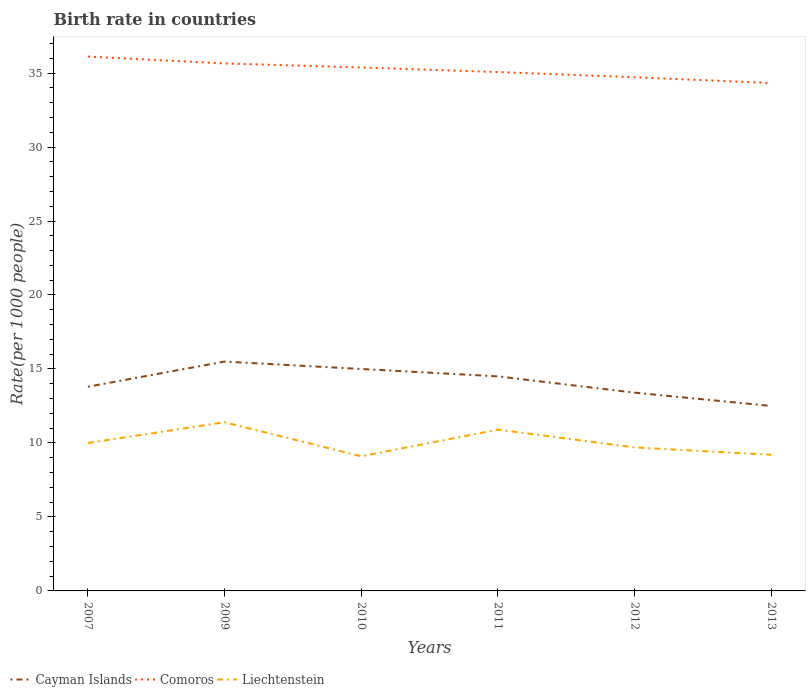How many different coloured lines are there?
Keep it short and to the point. 3. Does the line corresponding to Cayman Islands intersect with the line corresponding to Liechtenstein?
Offer a terse response. No. Across all years, what is the maximum birth rate in Liechtenstein?
Make the answer very short. 9.1. In which year was the birth rate in Comoros maximum?
Provide a succinct answer. 2013. What is the total birth rate in Cayman Islands in the graph?
Offer a terse response. 0.5. What is the difference between the highest and the second highest birth rate in Comoros?
Ensure brevity in your answer.  1.79. Is the birth rate in Cayman Islands strictly greater than the birth rate in Liechtenstein over the years?
Make the answer very short. No. How many years are there in the graph?
Your answer should be very brief. 6. What is the difference between two consecutive major ticks on the Y-axis?
Provide a short and direct response. 5. Are the values on the major ticks of Y-axis written in scientific E-notation?
Give a very brief answer. No. Does the graph contain any zero values?
Offer a very short reply. No. Does the graph contain grids?
Give a very brief answer. No. Where does the legend appear in the graph?
Provide a short and direct response. Bottom left. How many legend labels are there?
Ensure brevity in your answer.  3. What is the title of the graph?
Offer a very short reply. Birth rate in countries. What is the label or title of the Y-axis?
Your response must be concise. Rate(per 1000 people). What is the Rate(per 1000 people) of Cayman Islands in 2007?
Provide a short and direct response. 13.8. What is the Rate(per 1000 people) in Comoros in 2007?
Your answer should be very brief. 36.12. What is the Rate(per 1000 people) in Liechtenstein in 2007?
Provide a succinct answer. 10. What is the Rate(per 1000 people) in Comoros in 2009?
Provide a succinct answer. 35.65. What is the Rate(per 1000 people) in Comoros in 2010?
Provide a short and direct response. 35.38. What is the Rate(per 1000 people) in Liechtenstein in 2010?
Your answer should be compact. 9.1. What is the Rate(per 1000 people) of Comoros in 2011?
Your answer should be compact. 35.07. What is the Rate(per 1000 people) in Liechtenstein in 2011?
Offer a very short reply. 10.9. What is the Rate(per 1000 people) in Cayman Islands in 2012?
Offer a very short reply. 13.4. What is the Rate(per 1000 people) of Comoros in 2012?
Keep it short and to the point. 34.72. What is the Rate(per 1000 people) of Cayman Islands in 2013?
Your response must be concise. 12.5. What is the Rate(per 1000 people) in Comoros in 2013?
Your answer should be compact. 34.33. What is the Rate(per 1000 people) of Liechtenstein in 2013?
Ensure brevity in your answer.  9.2. Across all years, what is the maximum Rate(per 1000 people) of Cayman Islands?
Your answer should be very brief. 15.5. Across all years, what is the maximum Rate(per 1000 people) in Comoros?
Make the answer very short. 36.12. Across all years, what is the maximum Rate(per 1000 people) in Liechtenstein?
Give a very brief answer. 11.4. Across all years, what is the minimum Rate(per 1000 people) in Comoros?
Provide a short and direct response. 34.33. What is the total Rate(per 1000 people) in Cayman Islands in the graph?
Offer a terse response. 84.7. What is the total Rate(per 1000 people) of Comoros in the graph?
Your response must be concise. 211.25. What is the total Rate(per 1000 people) in Liechtenstein in the graph?
Keep it short and to the point. 60.3. What is the difference between the Rate(per 1000 people) of Comoros in 2007 and that in 2009?
Provide a short and direct response. 0.47. What is the difference between the Rate(per 1000 people) in Liechtenstein in 2007 and that in 2009?
Give a very brief answer. -1.4. What is the difference between the Rate(per 1000 people) in Cayman Islands in 2007 and that in 2010?
Make the answer very short. -1.2. What is the difference between the Rate(per 1000 people) of Comoros in 2007 and that in 2010?
Ensure brevity in your answer.  0.74. What is the difference between the Rate(per 1000 people) of Liechtenstein in 2007 and that in 2010?
Give a very brief answer. 0.9. What is the difference between the Rate(per 1000 people) of Comoros in 2007 and that in 2011?
Offer a very short reply. 1.05. What is the difference between the Rate(per 1000 people) of Cayman Islands in 2007 and that in 2012?
Keep it short and to the point. 0.4. What is the difference between the Rate(per 1000 people) in Comoros in 2007 and that in 2012?
Provide a short and direct response. 1.4. What is the difference between the Rate(per 1000 people) of Liechtenstein in 2007 and that in 2012?
Your answer should be very brief. 0.3. What is the difference between the Rate(per 1000 people) of Comoros in 2007 and that in 2013?
Your response must be concise. 1.79. What is the difference between the Rate(per 1000 people) of Liechtenstein in 2007 and that in 2013?
Offer a terse response. 0.8. What is the difference between the Rate(per 1000 people) of Cayman Islands in 2009 and that in 2010?
Give a very brief answer. 0.5. What is the difference between the Rate(per 1000 people) of Comoros in 2009 and that in 2010?
Ensure brevity in your answer.  0.27. What is the difference between the Rate(per 1000 people) of Liechtenstein in 2009 and that in 2010?
Your answer should be very brief. 2.3. What is the difference between the Rate(per 1000 people) of Comoros in 2009 and that in 2011?
Make the answer very short. 0.58. What is the difference between the Rate(per 1000 people) in Cayman Islands in 2009 and that in 2012?
Offer a very short reply. 2.1. What is the difference between the Rate(per 1000 people) in Liechtenstein in 2009 and that in 2012?
Your response must be concise. 1.7. What is the difference between the Rate(per 1000 people) of Cayman Islands in 2009 and that in 2013?
Offer a terse response. 3. What is the difference between the Rate(per 1000 people) of Comoros in 2009 and that in 2013?
Provide a short and direct response. 1.32. What is the difference between the Rate(per 1000 people) in Comoros in 2010 and that in 2011?
Provide a succinct answer. 0.31. What is the difference between the Rate(per 1000 people) in Comoros in 2010 and that in 2012?
Ensure brevity in your answer.  0.66. What is the difference between the Rate(per 1000 people) of Cayman Islands in 2010 and that in 2013?
Your response must be concise. 2.5. What is the difference between the Rate(per 1000 people) of Comoros in 2010 and that in 2013?
Your answer should be compact. 1.05. What is the difference between the Rate(per 1000 people) of Comoros in 2011 and that in 2012?
Your answer should be compact. 0.35. What is the difference between the Rate(per 1000 people) of Liechtenstein in 2011 and that in 2012?
Offer a very short reply. 1.2. What is the difference between the Rate(per 1000 people) in Cayman Islands in 2011 and that in 2013?
Your answer should be very brief. 2. What is the difference between the Rate(per 1000 people) of Comoros in 2011 and that in 2013?
Your answer should be compact. 0.74. What is the difference between the Rate(per 1000 people) of Comoros in 2012 and that in 2013?
Provide a succinct answer. 0.39. What is the difference between the Rate(per 1000 people) of Cayman Islands in 2007 and the Rate(per 1000 people) of Comoros in 2009?
Your answer should be compact. -21.85. What is the difference between the Rate(per 1000 people) of Cayman Islands in 2007 and the Rate(per 1000 people) of Liechtenstein in 2009?
Your answer should be very brief. 2.4. What is the difference between the Rate(per 1000 people) in Comoros in 2007 and the Rate(per 1000 people) in Liechtenstein in 2009?
Make the answer very short. 24.71. What is the difference between the Rate(per 1000 people) in Cayman Islands in 2007 and the Rate(per 1000 people) in Comoros in 2010?
Give a very brief answer. -21.58. What is the difference between the Rate(per 1000 people) of Comoros in 2007 and the Rate(per 1000 people) of Liechtenstein in 2010?
Keep it short and to the point. 27.02. What is the difference between the Rate(per 1000 people) in Cayman Islands in 2007 and the Rate(per 1000 people) in Comoros in 2011?
Give a very brief answer. -21.27. What is the difference between the Rate(per 1000 people) in Cayman Islands in 2007 and the Rate(per 1000 people) in Liechtenstein in 2011?
Ensure brevity in your answer.  2.9. What is the difference between the Rate(per 1000 people) in Comoros in 2007 and the Rate(per 1000 people) in Liechtenstein in 2011?
Give a very brief answer. 25.21. What is the difference between the Rate(per 1000 people) of Cayman Islands in 2007 and the Rate(per 1000 people) of Comoros in 2012?
Ensure brevity in your answer.  -20.92. What is the difference between the Rate(per 1000 people) of Comoros in 2007 and the Rate(per 1000 people) of Liechtenstein in 2012?
Your answer should be compact. 26.41. What is the difference between the Rate(per 1000 people) of Cayman Islands in 2007 and the Rate(per 1000 people) of Comoros in 2013?
Offer a very short reply. -20.53. What is the difference between the Rate(per 1000 people) in Cayman Islands in 2007 and the Rate(per 1000 people) in Liechtenstein in 2013?
Provide a succinct answer. 4.6. What is the difference between the Rate(per 1000 people) of Comoros in 2007 and the Rate(per 1000 people) of Liechtenstein in 2013?
Your answer should be compact. 26.91. What is the difference between the Rate(per 1000 people) in Cayman Islands in 2009 and the Rate(per 1000 people) in Comoros in 2010?
Ensure brevity in your answer.  -19.88. What is the difference between the Rate(per 1000 people) in Comoros in 2009 and the Rate(per 1000 people) in Liechtenstein in 2010?
Your answer should be very brief. 26.55. What is the difference between the Rate(per 1000 people) in Cayman Islands in 2009 and the Rate(per 1000 people) in Comoros in 2011?
Your answer should be very brief. -19.57. What is the difference between the Rate(per 1000 people) in Comoros in 2009 and the Rate(per 1000 people) in Liechtenstein in 2011?
Make the answer very short. 24.75. What is the difference between the Rate(per 1000 people) in Cayman Islands in 2009 and the Rate(per 1000 people) in Comoros in 2012?
Provide a succinct answer. -19.22. What is the difference between the Rate(per 1000 people) of Cayman Islands in 2009 and the Rate(per 1000 people) of Liechtenstein in 2012?
Ensure brevity in your answer.  5.8. What is the difference between the Rate(per 1000 people) of Comoros in 2009 and the Rate(per 1000 people) of Liechtenstein in 2012?
Provide a succinct answer. 25.95. What is the difference between the Rate(per 1000 people) in Cayman Islands in 2009 and the Rate(per 1000 people) in Comoros in 2013?
Your answer should be very brief. -18.83. What is the difference between the Rate(per 1000 people) of Cayman Islands in 2009 and the Rate(per 1000 people) of Liechtenstein in 2013?
Offer a terse response. 6.3. What is the difference between the Rate(per 1000 people) in Comoros in 2009 and the Rate(per 1000 people) in Liechtenstein in 2013?
Ensure brevity in your answer.  26.45. What is the difference between the Rate(per 1000 people) in Cayman Islands in 2010 and the Rate(per 1000 people) in Comoros in 2011?
Make the answer very short. -20.07. What is the difference between the Rate(per 1000 people) in Cayman Islands in 2010 and the Rate(per 1000 people) in Liechtenstein in 2011?
Give a very brief answer. 4.1. What is the difference between the Rate(per 1000 people) in Comoros in 2010 and the Rate(per 1000 people) in Liechtenstein in 2011?
Your response must be concise. 24.48. What is the difference between the Rate(per 1000 people) of Cayman Islands in 2010 and the Rate(per 1000 people) of Comoros in 2012?
Provide a succinct answer. -19.72. What is the difference between the Rate(per 1000 people) of Comoros in 2010 and the Rate(per 1000 people) of Liechtenstein in 2012?
Provide a succinct answer. 25.68. What is the difference between the Rate(per 1000 people) of Cayman Islands in 2010 and the Rate(per 1000 people) of Comoros in 2013?
Make the answer very short. -19.33. What is the difference between the Rate(per 1000 people) of Comoros in 2010 and the Rate(per 1000 people) of Liechtenstein in 2013?
Your answer should be compact. 26.18. What is the difference between the Rate(per 1000 people) of Cayman Islands in 2011 and the Rate(per 1000 people) of Comoros in 2012?
Ensure brevity in your answer.  -20.22. What is the difference between the Rate(per 1000 people) in Cayman Islands in 2011 and the Rate(per 1000 people) in Liechtenstein in 2012?
Your response must be concise. 4.8. What is the difference between the Rate(per 1000 people) of Comoros in 2011 and the Rate(per 1000 people) of Liechtenstein in 2012?
Ensure brevity in your answer.  25.37. What is the difference between the Rate(per 1000 people) in Cayman Islands in 2011 and the Rate(per 1000 people) in Comoros in 2013?
Keep it short and to the point. -19.83. What is the difference between the Rate(per 1000 people) in Cayman Islands in 2011 and the Rate(per 1000 people) in Liechtenstein in 2013?
Your answer should be very brief. 5.3. What is the difference between the Rate(per 1000 people) of Comoros in 2011 and the Rate(per 1000 people) of Liechtenstein in 2013?
Keep it short and to the point. 25.87. What is the difference between the Rate(per 1000 people) of Cayman Islands in 2012 and the Rate(per 1000 people) of Comoros in 2013?
Your response must be concise. -20.93. What is the difference between the Rate(per 1000 people) in Cayman Islands in 2012 and the Rate(per 1000 people) in Liechtenstein in 2013?
Offer a terse response. 4.2. What is the difference between the Rate(per 1000 people) in Comoros in 2012 and the Rate(per 1000 people) in Liechtenstein in 2013?
Offer a terse response. 25.52. What is the average Rate(per 1000 people) in Cayman Islands per year?
Offer a very short reply. 14.12. What is the average Rate(per 1000 people) in Comoros per year?
Your response must be concise. 35.21. What is the average Rate(per 1000 people) of Liechtenstein per year?
Your answer should be very brief. 10.05. In the year 2007, what is the difference between the Rate(per 1000 people) of Cayman Islands and Rate(per 1000 people) of Comoros?
Provide a succinct answer. -22.32. In the year 2007, what is the difference between the Rate(per 1000 people) in Cayman Islands and Rate(per 1000 people) in Liechtenstein?
Make the answer very short. 3.8. In the year 2007, what is the difference between the Rate(per 1000 people) of Comoros and Rate(per 1000 people) of Liechtenstein?
Offer a terse response. 26.11. In the year 2009, what is the difference between the Rate(per 1000 people) of Cayman Islands and Rate(per 1000 people) of Comoros?
Offer a very short reply. -20.15. In the year 2009, what is the difference between the Rate(per 1000 people) in Comoros and Rate(per 1000 people) in Liechtenstein?
Give a very brief answer. 24.25. In the year 2010, what is the difference between the Rate(per 1000 people) of Cayman Islands and Rate(per 1000 people) of Comoros?
Provide a succinct answer. -20.38. In the year 2010, what is the difference between the Rate(per 1000 people) in Comoros and Rate(per 1000 people) in Liechtenstein?
Give a very brief answer. 26.28. In the year 2011, what is the difference between the Rate(per 1000 people) of Cayman Islands and Rate(per 1000 people) of Comoros?
Give a very brief answer. -20.57. In the year 2011, what is the difference between the Rate(per 1000 people) of Comoros and Rate(per 1000 people) of Liechtenstein?
Make the answer very short. 24.17. In the year 2012, what is the difference between the Rate(per 1000 people) in Cayman Islands and Rate(per 1000 people) in Comoros?
Provide a short and direct response. -21.32. In the year 2012, what is the difference between the Rate(per 1000 people) in Comoros and Rate(per 1000 people) in Liechtenstein?
Make the answer very short. 25.02. In the year 2013, what is the difference between the Rate(per 1000 people) in Cayman Islands and Rate(per 1000 people) in Comoros?
Your response must be concise. -21.83. In the year 2013, what is the difference between the Rate(per 1000 people) of Cayman Islands and Rate(per 1000 people) of Liechtenstein?
Your answer should be very brief. 3.3. In the year 2013, what is the difference between the Rate(per 1000 people) in Comoros and Rate(per 1000 people) in Liechtenstein?
Your response must be concise. 25.13. What is the ratio of the Rate(per 1000 people) of Cayman Islands in 2007 to that in 2009?
Offer a terse response. 0.89. What is the ratio of the Rate(per 1000 people) of Comoros in 2007 to that in 2009?
Offer a terse response. 1.01. What is the ratio of the Rate(per 1000 people) in Liechtenstein in 2007 to that in 2009?
Your response must be concise. 0.88. What is the ratio of the Rate(per 1000 people) of Cayman Islands in 2007 to that in 2010?
Your response must be concise. 0.92. What is the ratio of the Rate(per 1000 people) of Comoros in 2007 to that in 2010?
Provide a short and direct response. 1.02. What is the ratio of the Rate(per 1000 people) in Liechtenstein in 2007 to that in 2010?
Provide a short and direct response. 1.1. What is the ratio of the Rate(per 1000 people) in Cayman Islands in 2007 to that in 2011?
Provide a short and direct response. 0.95. What is the ratio of the Rate(per 1000 people) of Comoros in 2007 to that in 2011?
Your answer should be very brief. 1.03. What is the ratio of the Rate(per 1000 people) in Liechtenstein in 2007 to that in 2011?
Your response must be concise. 0.92. What is the ratio of the Rate(per 1000 people) in Cayman Islands in 2007 to that in 2012?
Your response must be concise. 1.03. What is the ratio of the Rate(per 1000 people) of Comoros in 2007 to that in 2012?
Offer a terse response. 1.04. What is the ratio of the Rate(per 1000 people) of Liechtenstein in 2007 to that in 2012?
Give a very brief answer. 1.03. What is the ratio of the Rate(per 1000 people) of Cayman Islands in 2007 to that in 2013?
Your answer should be very brief. 1.1. What is the ratio of the Rate(per 1000 people) of Comoros in 2007 to that in 2013?
Ensure brevity in your answer.  1.05. What is the ratio of the Rate(per 1000 people) of Liechtenstein in 2007 to that in 2013?
Make the answer very short. 1.09. What is the ratio of the Rate(per 1000 people) of Comoros in 2009 to that in 2010?
Keep it short and to the point. 1.01. What is the ratio of the Rate(per 1000 people) of Liechtenstein in 2009 to that in 2010?
Provide a succinct answer. 1.25. What is the ratio of the Rate(per 1000 people) in Cayman Islands in 2009 to that in 2011?
Provide a succinct answer. 1.07. What is the ratio of the Rate(per 1000 people) of Comoros in 2009 to that in 2011?
Keep it short and to the point. 1.02. What is the ratio of the Rate(per 1000 people) of Liechtenstein in 2009 to that in 2011?
Provide a succinct answer. 1.05. What is the ratio of the Rate(per 1000 people) of Cayman Islands in 2009 to that in 2012?
Your answer should be compact. 1.16. What is the ratio of the Rate(per 1000 people) in Comoros in 2009 to that in 2012?
Keep it short and to the point. 1.03. What is the ratio of the Rate(per 1000 people) in Liechtenstein in 2009 to that in 2012?
Keep it short and to the point. 1.18. What is the ratio of the Rate(per 1000 people) in Cayman Islands in 2009 to that in 2013?
Ensure brevity in your answer.  1.24. What is the ratio of the Rate(per 1000 people) of Comoros in 2009 to that in 2013?
Your response must be concise. 1.04. What is the ratio of the Rate(per 1000 people) in Liechtenstein in 2009 to that in 2013?
Make the answer very short. 1.24. What is the ratio of the Rate(per 1000 people) in Cayman Islands in 2010 to that in 2011?
Ensure brevity in your answer.  1.03. What is the ratio of the Rate(per 1000 people) of Comoros in 2010 to that in 2011?
Your answer should be very brief. 1.01. What is the ratio of the Rate(per 1000 people) in Liechtenstein in 2010 to that in 2011?
Offer a terse response. 0.83. What is the ratio of the Rate(per 1000 people) of Cayman Islands in 2010 to that in 2012?
Ensure brevity in your answer.  1.12. What is the ratio of the Rate(per 1000 people) in Liechtenstein in 2010 to that in 2012?
Keep it short and to the point. 0.94. What is the ratio of the Rate(per 1000 people) in Comoros in 2010 to that in 2013?
Your response must be concise. 1.03. What is the ratio of the Rate(per 1000 people) in Liechtenstein in 2010 to that in 2013?
Your answer should be compact. 0.99. What is the ratio of the Rate(per 1000 people) in Cayman Islands in 2011 to that in 2012?
Your response must be concise. 1.08. What is the ratio of the Rate(per 1000 people) of Liechtenstein in 2011 to that in 2012?
Make the answer very short. 1.12. What is the ratio of the Rate(per 1000 people) of Cayman Islands in 2011 to that in 2013?
Keep it short and to the point. 1.16. What is the ratio of the Rate(per 1000 people) in Comoros in 2011 to that in 2013?
Keep it short and to the point. 1.02. What is the ratio of the Rate(per 1000 people) in Liechtenstein in 2011 to that in 2013?
Your answer should be compact. 1.18. What is the ratio of the Rate(per 1000 people) of Cayman Islands in 2012 to that in 2013?
Offer a very short reply. 1.07. What is the ratio of the Rate(per 1000 people) in Comoros in 2012 to that in 2013?
Your response must be concise. 1.01. What is the ratio of the Rate(per 1000 people) of Liechtenstein in 2012 to that in 2013?
Ensure brevity in your answer.  1.05. What is the difference between the highest and the second highest Rate(per 1000 people) in Comoros?
Offer a very short reply. 0.47. What is the difference between the highest and the lowest Rate(per 1000 people) of Cayman Islands?
Offer a very short reply. 3. What is the difference between the highest and the lowest Rate(per 1000 people) of Comoros?
Provide a succinct answer. 1.79. What is the difference between the highest and the lowest Rate(per 1000 people) of Liechtenstein?
Offer a terse response. 2.3. 